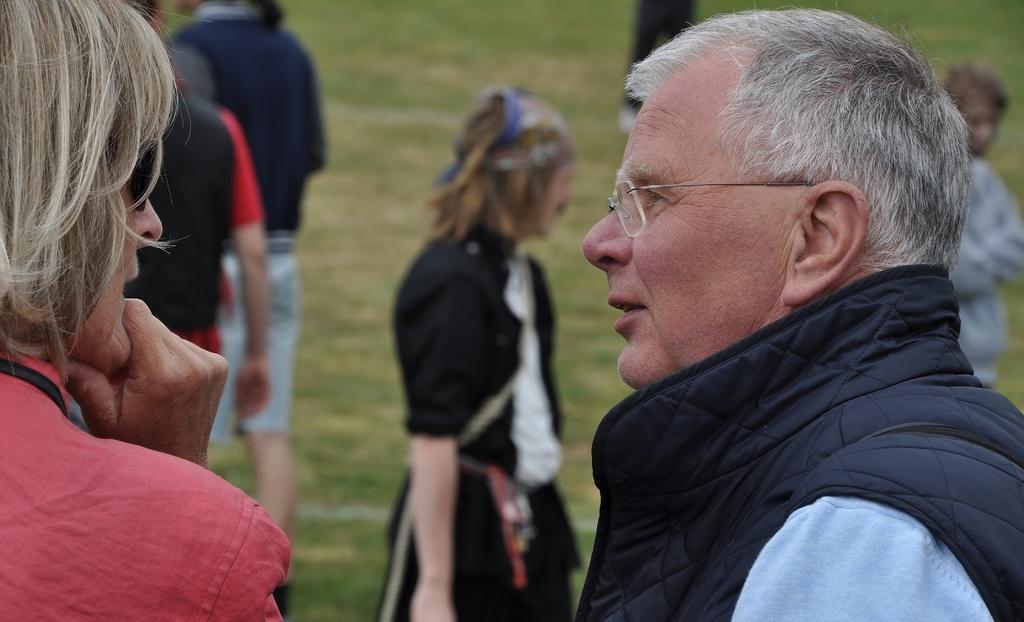Could you give a brief overview of what you see in this image? Here we can see few persons on the ground and this is grass. 